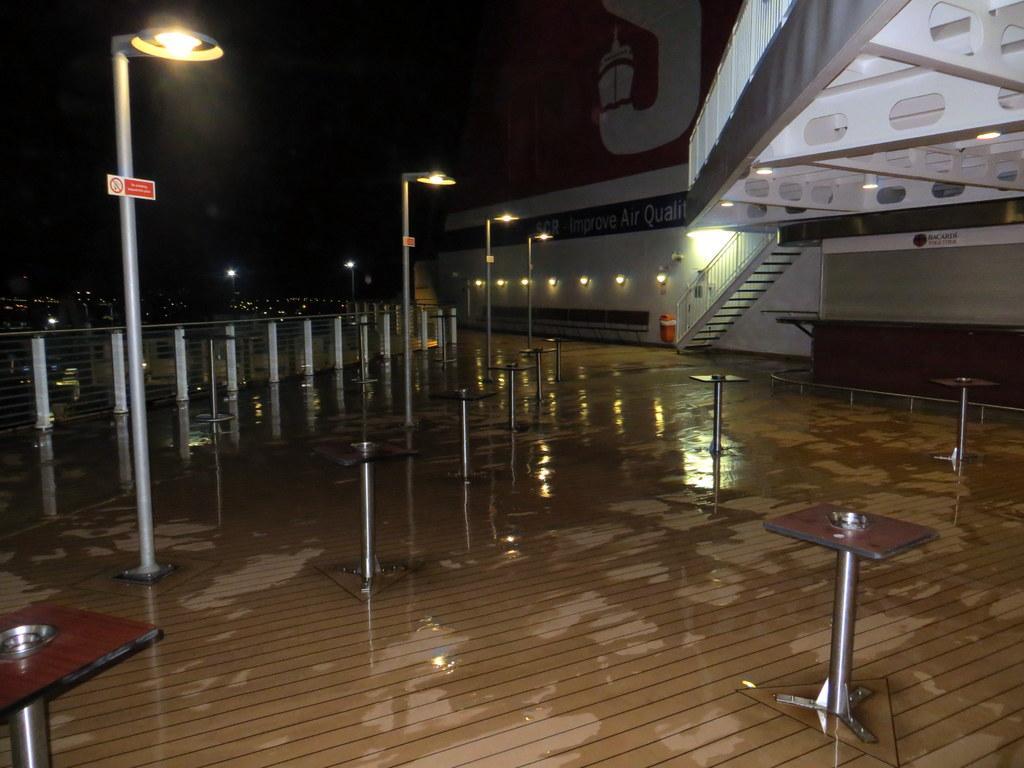How would you summarize this image in a sentence or two? In this image at the bottom there is floor, and also there are some poles and lights and some boards. And in the background there is a building, stairs and some lights and at the top there is sky. 